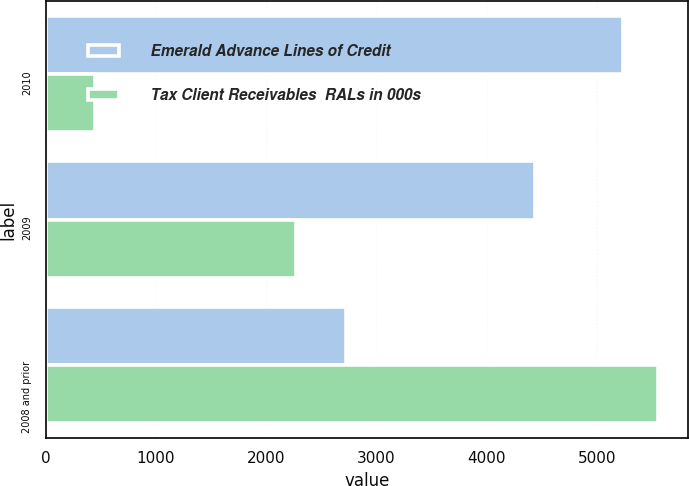Convert chart. <chart><loc_0><loc_0><loc_500><loc_500><stacked_bar_chart><ecel><fcel>2010<fcel>2009<fcel>2008 and prior<nl><fcel>Emerald Advance Lines of Credit<fcel>5236<fcel>4443<fcel>2722<nl><fcel>Tax Client Receivables  RALs in 000s<fcel>446<fcel>2270<fcel>5551<nl></chart> 